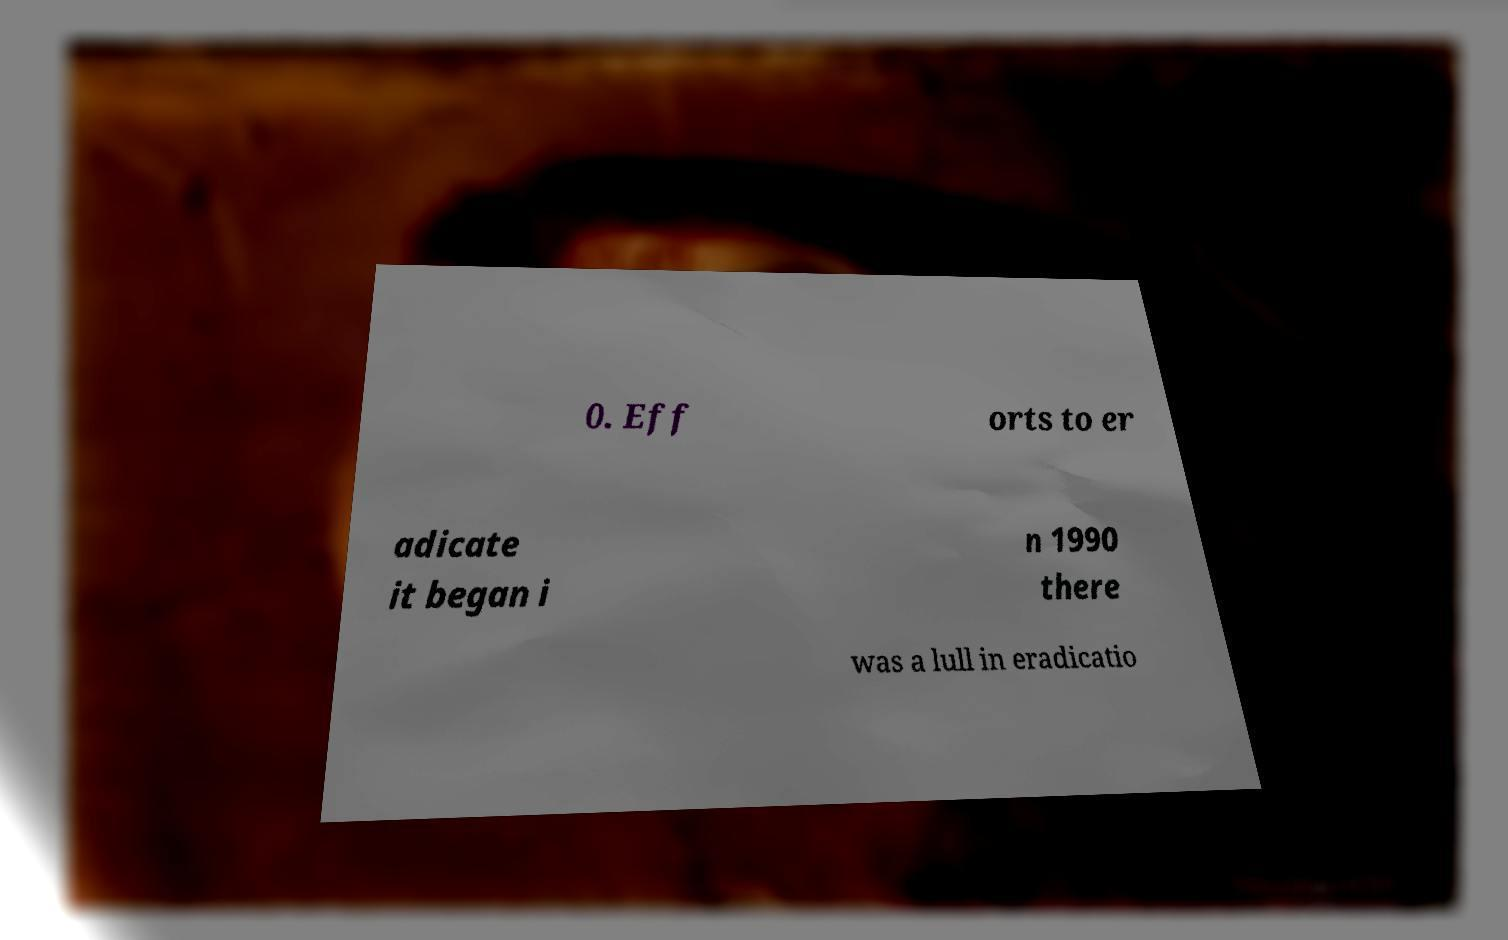There's text embedded in this image that I need extracted. Can you transcribe it verbatim? 0. Eff orts to er adicate it began i n 1990 there was a lull in eradicatio 